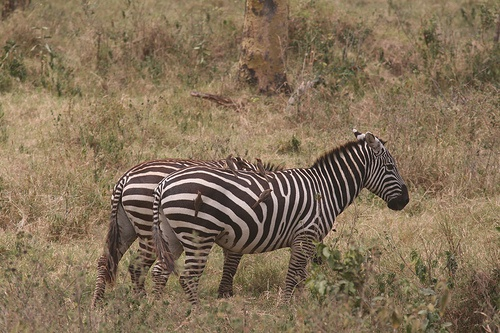Describe the objects in this image and their specific colors. I can see zebra in gray, black, and darkgray tones, zebra in gray, black, and maroon tones, bird in gray, black, brown, and maroon tones, bird in gray, black, maroon, and lightgray tones, and bird in gray, black, and maroon tones in this image. 